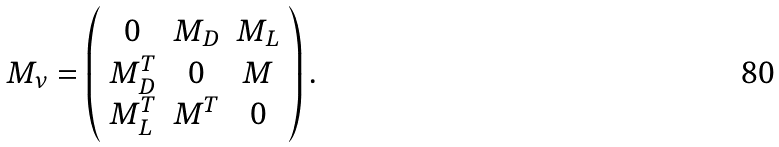<formula> <loc_0><loc_0><loc_500><loc_500>M _ { \nu } = \left ( \begin{array} { c c c } 0 & M _ { D } & M _ { L } \\ M _ { D } ^ { T } & 0 & M \\ M _ { L } ^ { T } & M ^ { T } & 0 \end{array} \right ) .</formula> 